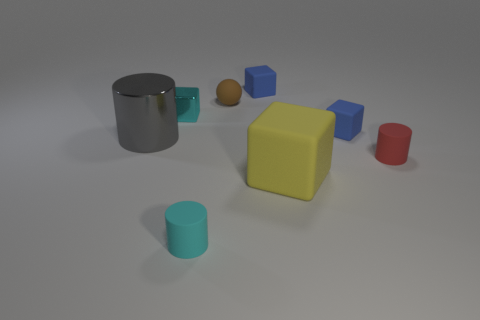What is the color of the small ball that is made of the same material as the big cube?
Offer a very short reply. Brown. Is the number of rubber cylinders less than the number of cubes?
Make the answer very short. Yes. There is a big metal thing that is left of the tiny red rubber object; is it the same shape as the rubber object that is to the left of the brown rubber sphere?
Ensure brevity in your answer.  Yes. How many objects are either big cylinders or big green metal things?
Keep it short and to the point. 1. What color is the rubber sphere that is the same size as the cyan cylinder?
Make the answer very short. Brown. There is a small cyan object that is in front of the large cylinder; how many small cubes are right of it?
Your answer should be very brief. 2. How many blocks are to the left of the small brown matte sphere and in front of the red matte object?
Offer a terse response. 0. What number of things are either things that are behind the cyan metal object or rubber cubes that are in front of the rubber sphere?
Your answer should be very brief. 4. How many other objects are there of the same size as the brown object?
Your answer should be very brief. 5. What is the shape of the tiny blue thing that is behind the tiny cyan object behind the large gray metallic thing?
Your answer should be very brief. Cube. 